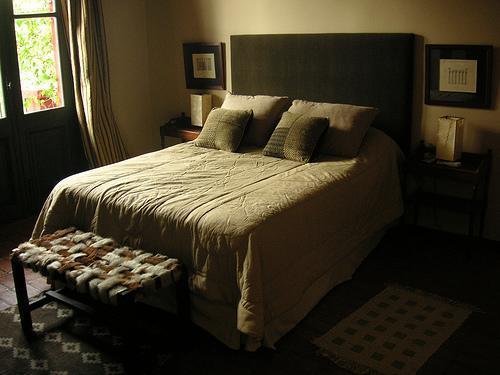How many pillows are there?
Give a very brief answer. 4. 